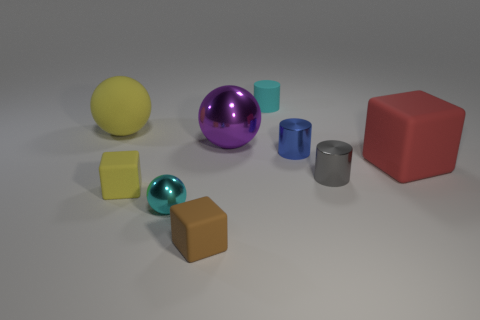Subtract 1 cylinders. How many cylinders are left? 2 Add 1 small green objects. How many objects exist? 10 Subtract all blocks. How many objects are left? 6 Add 2 small brown blocks. How many small brown blocks are left? 3 Add 1 large things. How many large things exist? 4 Subtract 1 cyan balls. How many objects are left? 8 Subtract all cyan cylinders. Subtract all small rubber objects. How many objects are left? 5 